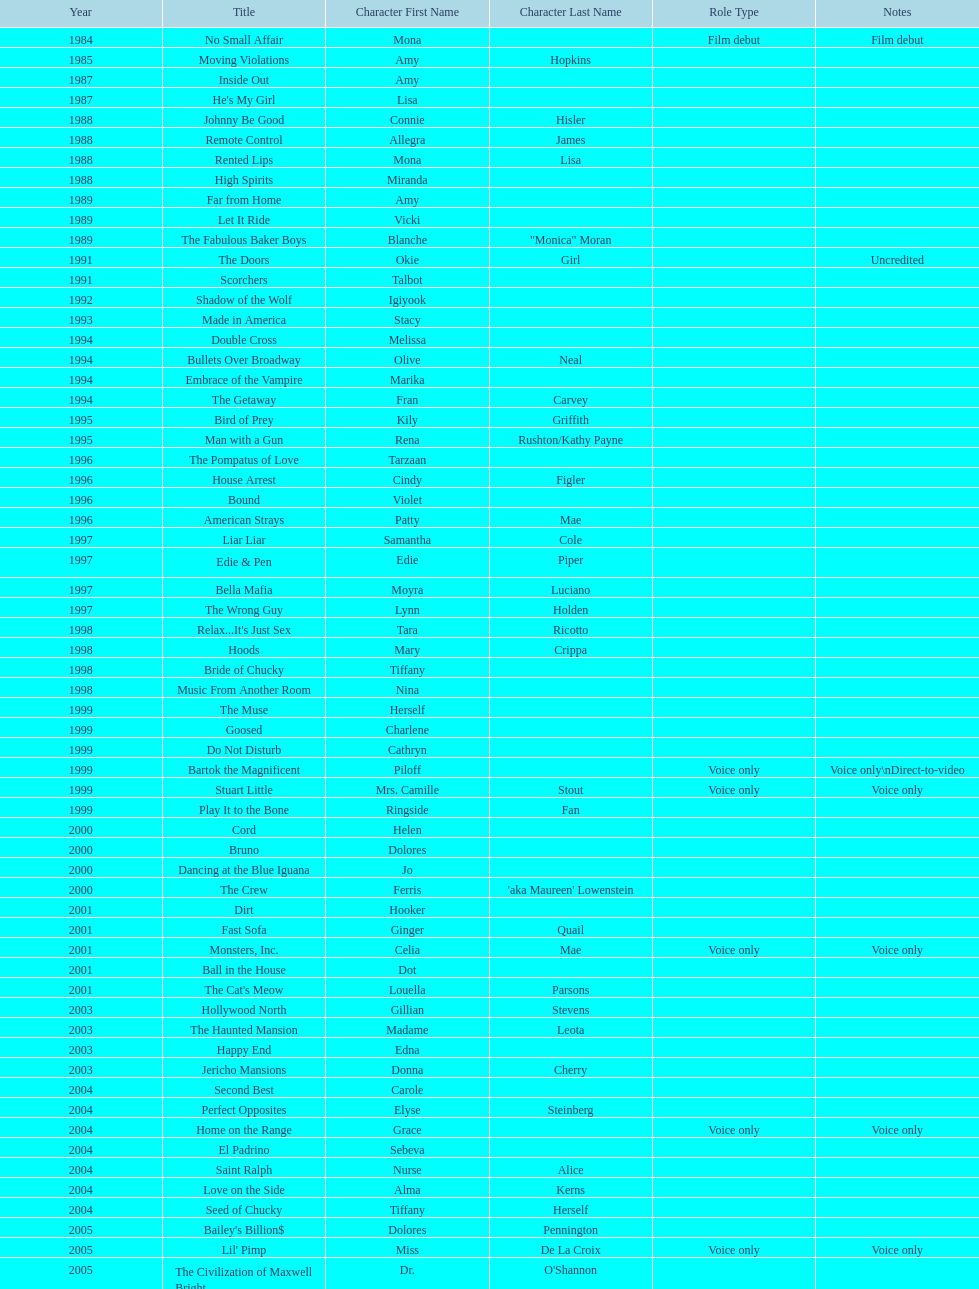Could you parse the entire table? {'header': ['Year', 'Title', 'Character First Name', 'Character Last Name', 'Role Type', 'Notes'], 'rows': [['1984', 'No Small Affair', 'Mona', '', 'Film debut', 'Film debut'], ['1985', 'Moving Violations', 'Amy', 'Hopkins', '', ''], ['1987', 'Inside Out', 'Amy', '', '', ''], ['1987', "He's My Girl", 'Lisa', '', '', ''], ['1988', 'Johnny Be Good', 'Connie', 'Hisler', '', ''], ['1988', 'Remote Control', 'Allegra', 'James', '', ''], ['1988', 'Rented Lips', 'Mona', 'Lisa', '', ''], ['1988', 'High Spirits', 'Miranda', '', '', ''], ['1989', 'Far from Home', 'Amy', '', '', ''], ['1989', 'Let It Ride', 'Vicki', '', '', ''], ['1989', 'The Fabulous Baker Boys', 'Blanche', '"Monica" Moran', '', ''], ['1991', 'The Doors', 'Okie', 'Girl', '', 'Uncredited'], ['1991', 'Scorchers', 'Talbot', '', '', ''], ['1992', 'Shadow of the Wolf', 'Igiyook', '', '', ''], ['1993', 'Made in America', 'Stacy', '', '', ''], ['1994', 'Double Cross', 'Melissa', '', '', ''], ['1994', 'Bullets Over Broadway', 'Olive', 'Neal', '', ''], ['1994', 'Embrace of the Vampire', 'Marika', '', '', ''], ['1994', 'The Getaway', 'Fran', 'Carvey', '', ''], ['1995', 'Bird of Prey', 'Kily', 'Griffith', '', ''], ['1995', 'Man with a Gun', 'Rena', 'Rushton/Kathy Payne', '', ''], ['1996', 'The Pompatus of Love', 'Tarzaan', '', '', ''], ['1996', 'House Arrest', 'Cindy', 'Figler', '', ''], ['1996', 'Bound', 'Violet', '', '', ''], ['1996', 'American Strays', 'Patty', 'Mae', '', ''], ['1997', 'Liar Liar', 'Samantha', 'Cole', '', ''], ['1997', 'Edie & Pen', 'Edie', 'Piper', '', ''], ['1997', 'Bella Mafia', 'Moyra', 'Luciano', '', ''], ['1997', 'The Wrong Guy', 'Lynn', 'Holden', '', ''], ['1998', "Relax...It's Just Sex", 'Tara', 'Ricotto', '', ''], ['1998', 'Hoods', 'Mary', 'Crippa', '', ''], ['1998', 'Bride of Chucky', 'Tiffany', '', '', ''], ['1998', 'Music From Another Room', 'Nina', '', '', ''], ['1999', 'The Muse', 'Herself', '', '', ''], ['1999', 'Goosed', 'Charlene', '', '', ''], ['1999', 'Do Not Disturb', 'Cathryn', '', '', ''], ['1999', 'Bartok the Magnificent', 'Piloff', '', 'Voice only', 'Voice only\\nDirect-to-video'], ['1999', 'Stuart Little', 'Mrs. Camille', 'Stout', 'Voice only', 'Voice only'], ['1999', 'Play It to the Bone', 'Ringside', 'Fan', '', ''], ['2000', 'Cord', 'Helen', '', '', ''], ['2000', 'Bruno', 'Dolores', '', '', ''], ['2000', 'Dancing at the Blue Iguana', 'Jo', '', '', ''], ['2000', 'The Crew', 'Ferris', "'aka Maureen' Lowenstein", '', ''], ['2001', 'Dirt', 'Hooker', '', '', ''], ['2001', 'Fast Sofa', 'Ginger', 'Quail', '', ''], ['2001', 'Monsters, Inc.', 'Celia', 'Mae', 'Voice only', 'Voice only'], ['2001', 'Ball in the House', 'Dot', '', '', ''], ['2001', "The Cat's Meow", 'Louella', 'Parsons', '', ''], ['2003', 'Hollywood North', 'Gillian', 'Stevens', '', ''], ['2003', 'The Haunted Mansion', 'Madame', 'Leota', '', ''], ['2003', 'Happy End', 'Edna', '', '', ''], ['2003', 'Jericho Mansions', 'Donna', 'Cherry', '', ''], ['2004', 'Second Best', 'Carole', '', '', ''], ['2004', 'Perfect Opposites', 'Elyse', 'Steinberg', '', ''], ['2004', 'Home on the Range', 'Grace', '', 'Voice only', 'Voice only'], ['2004', 'El Padrino', 'Sebeva', '', '', ''], ['2004', 'Saint Ralph', 'Nurse', 'Alice', '', ''], ['2004', 'Love on the Side', 'Alma', 'Kerns', '', ''], ['2004', 'Seed of Chucky', 'Tiffany', 'Herself', '', ''], ['2005', "Bailey's Billion$", 'Dolores', 'Pennington', '', ''], ['2005', "Lil' Pimp", 'Miss', 'De La Croix', 'Voice only', 'Voice only'], ['2005', 'The Civilization of Maxwell Bright', 'Dr.', "O'Shannon", '', ''], ['2005', 'Tideland', 'Queen', 'Gunhilda', '', ''], ['2006', 'The Poker Movie', 'Herself', '', '', ''], ['2007', 'Intervention', '', '', '', ''], ['2008', 'Deal', 'Karen', "'Razor' Jones", '', ''], ['2008', 'The Caretaker', 'Miss', 'Perry', '', ''], ['2008', 'Bart Got a Room', 'Melinda', '', '', ''], ['2008', 'Inconceivable', 'Salome', "'Sally' Marsh", '', ''], ['2009', 'An American Girl: Chrissa Stands Strong', 'Mrs.', 'Rundell', '', ''], ['2009', 'Imps', '', '', '', ''], ['2009', 'Made in Romania', 'Herself', '', '', ''], ['2009', 'Empire of Silver', 'Mrs.', 'Landdeck', '', ''], ['2010', 'The Making of Plus One', 'Amber', '', '', ''], ['2010', 'The Secret Lives of Dorks', 'Ms.', 'Stewart', '', ''], ['2012', '30 Beats', 'Erika', '', '', ''], ['2013', 'Curse of Chucky', 'Tiffany', 'Ray', 'Cameo', 'Cameo, Direct-to-video']]} Which year had the most credits? 2004. 